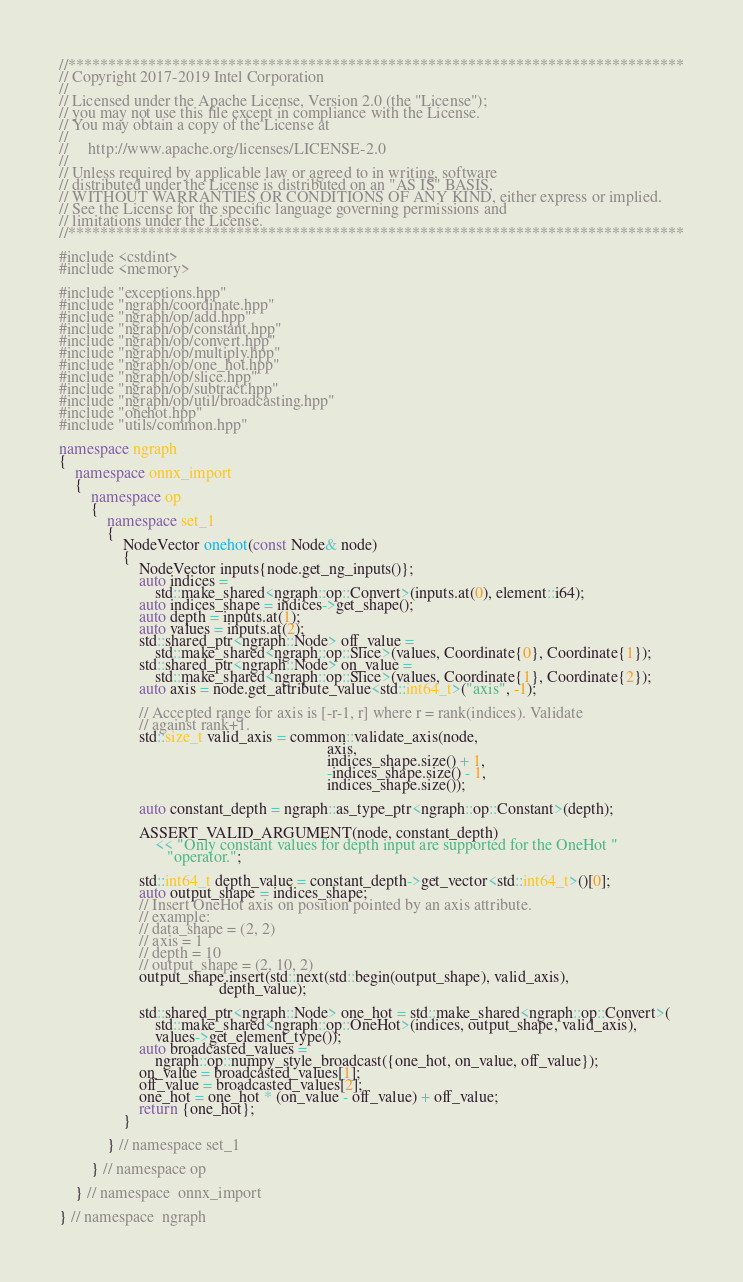<code> <loc_0><loc_0><loc_500><loc_500><_C++_>//*****************************************************************************
// Copyright 2017-2019 Intel Corporation
//
// Licensed under the Apache License, Version 2.0 (the "License");
// you may not use this file except in compliance with the License.
// You may obtain a copy of the License at
//
//     http://www.apache.org/licenses/LICENSE-2.0
//
// Unless required by applicable law or agreed to in writing, software
// distributed under the License is distributed on an "AS IS" BASIS,
// WITHOUT WARRANTIES OR CONDITIONS OF ANY KIND, either express or implied.
// See the License for the specific language governing permissions and
// limitations under the License.
//*****************************************************************************

#include <cstdint>
#include <memory>

#include "exceptions.hpp"
#include "ngraph/coordinate.hpp"
#include "ngraph/op/add.hpp"
#include "ngraph/op/constant.hpp"
#include "ngraph/op/convert.hpp"
#include "ngraph/op/multiply.hpp"
#include "ngraph/op/one_hot.hpp"
#include "ngraph/op/slice.hpp"
#include "ngraph/op/subtract.hpp"
#include "ngraph/op/util/broadcasting.hpp"
#include "onehot.hpp"
#include "utils/common.hpp"

namespace ngraph
{
    namespace onnx_import
    {
        namespace op
        {
            namespace set_1
            {
                NodeVector onehot(const Node& node)
                {
                    NodeVector inputs{node.get_ng_inputs()};
                    auto indices =
                        std::make_shared<ngraph::op::Convert>(inputs.at(0), element::i64);
                    auto indices_shape = indices->get_shape();
                    auto depth = inputs.at(1);
                    auto values = inputs.at(2);
                    std::shared_ptr<ngraph::Node> off_value =
                        std::make_shared<ngraph::op::Slice>(values, Coordinate{0}, Coordinate{1});
                    std::shared_ptr<ngraph::Node> on_value =
                        std::make_shared<ngraph::op::Slice>(values, Coordinate{1}, Coordinate{2});
                    auto axis = node.get_attribute_value<std::int64_t>("axis", -1);

                    // Accepted range for axis is [-r-1, r] where r = rank(indices). Validate
                    // against rank+1.
                    std::size_t valid_axis = common::validate_axis(node,
                                                                   axis,
                                                                   indices_shape.size() + 1,
                                                                   -indices_shape.size() - 1,
                                                                   indices_shape.size());

                    auto constant_depth = ngraph::as_type_ptr<ngraph::op::Constant>(depth);

                    ASSERT_VALID_ARGUMENT(node, constant_depth)
                        << "Only constant values for depth input are supported for the OneHot "
                           "operator.";

                    std::int64_t depth_value = constant_depth->get_vector<std::int64_t>()[0];
                    auto output_shape = indices_shape;
                    // Insert OneHot axis on position pointed by an axis attribute.
                    // example:
                    // data_shape = (2, 2)
                    // axis = 1
                    // depth = 10
                    // output_shape = (2, 10, 2)
                    output_shape.insert(std::next(std::begin(output_shape), valid_axis),
                                        depth_value);

                    std::shared_ptr<ngraph::Node> one_hot = std::make_shared<ngraph::op::Convert>(
                        std::make_shared<ngraph::op::OneHot>(indices, output_shape, valid_axis),
                        values->get_element_type());
                    auto broadcasted_values =
                        ngraph::op::numpy_style_broadcast({one_hot, on_value, off_value});
                    on_value = broadcasted_values[1];
                    off_value = broadcasted_values[2];
                    one_hot = one_hot * (on_value - off_value) + off_value;
                    return {one_hot};
                }

            } // namespace set_1

        } // namespace op

    } // namespace  onnx_import

} // namespace  ngraph
</code> 